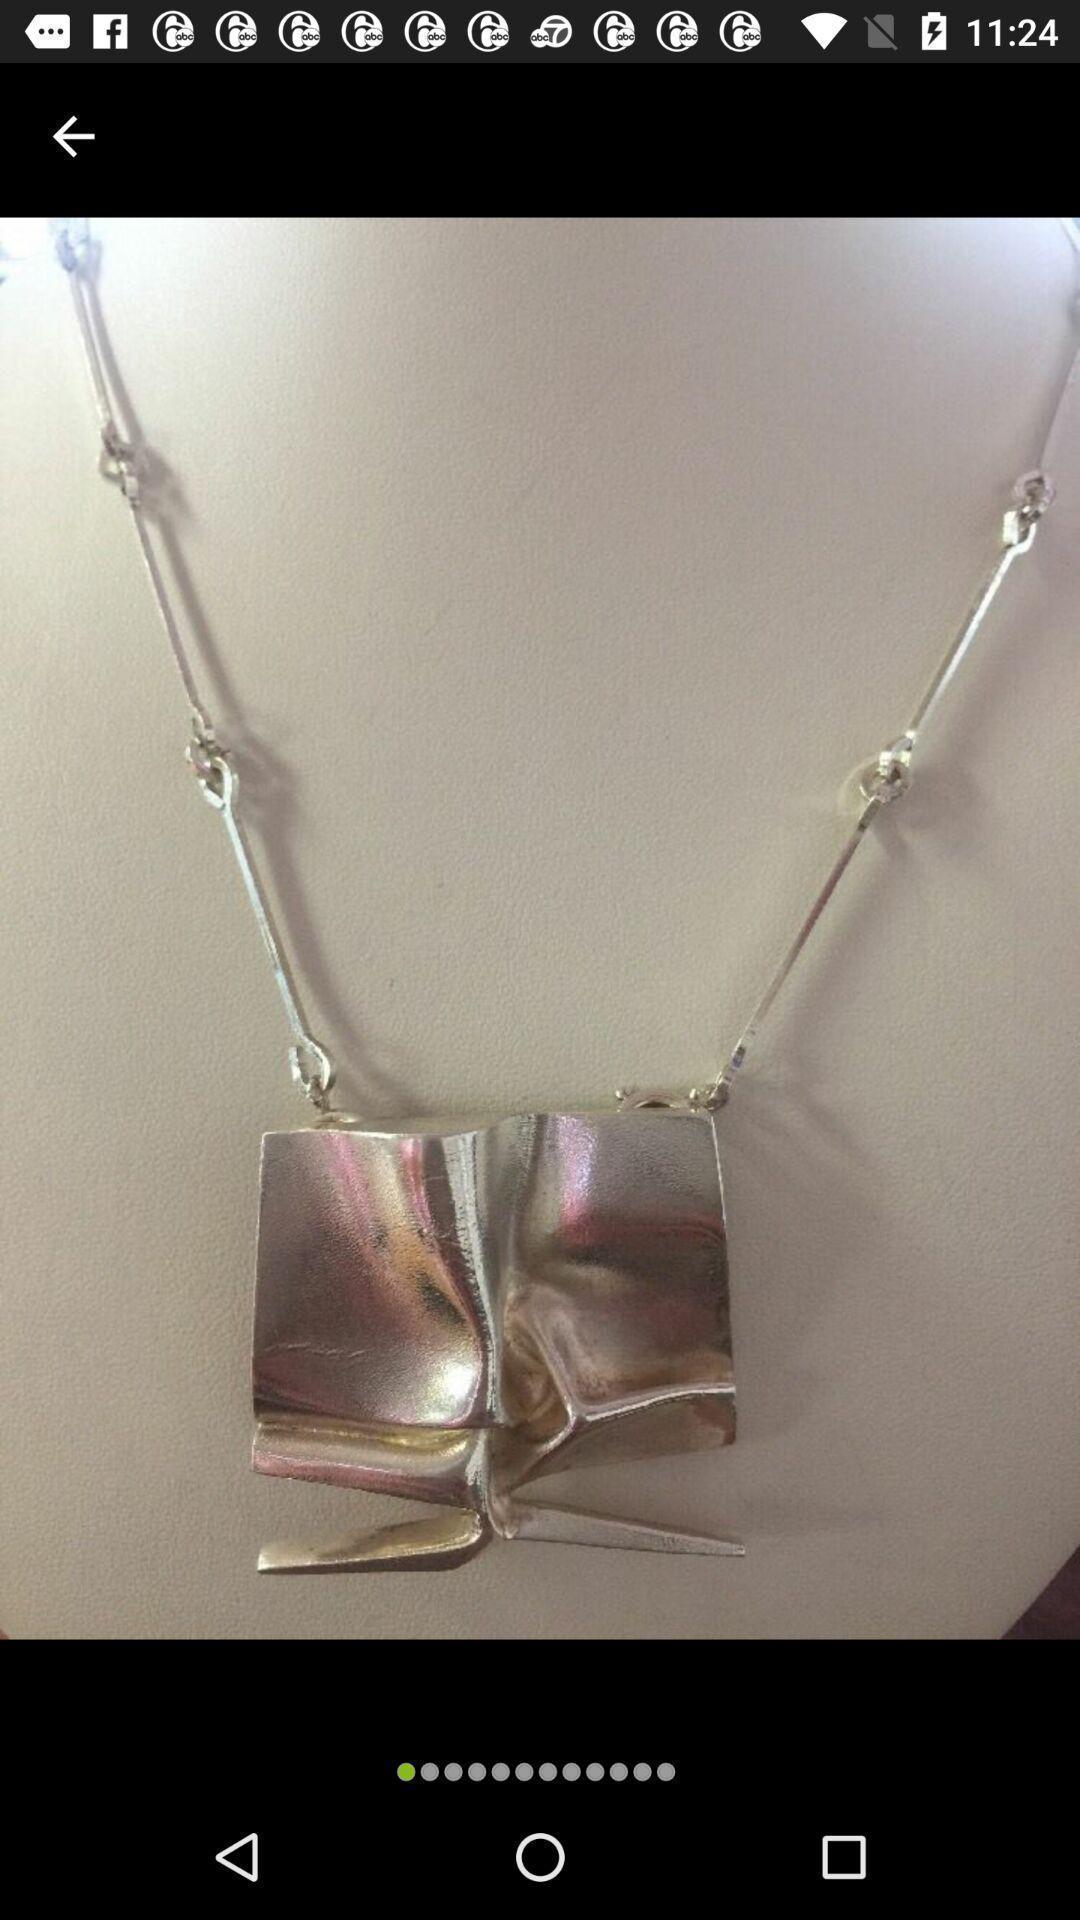What can you discern from this picture? Page showing the image of a jewellery. 